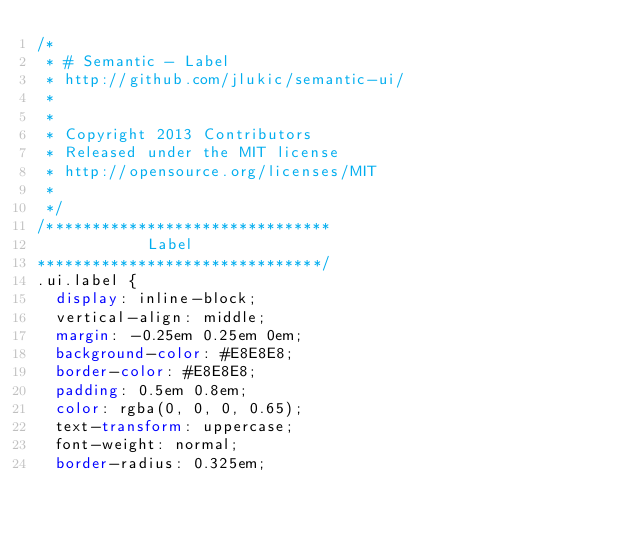Convert code to text. <code><loc_0><loc_0><loc_500><loc_500><_CSS_>/*
 * # Semantic - Label
 * http://github.com/jlukic/semantic-ui/
 *
 *
 * Copyright 2013 Contributors
 * Released under the MIT license
 * http://opensource.org/licenses/MIT
 *
 */
/*******************************
            Label
*******************************/
.ui.label {
  display: inline-block;
  vertical-align: middle;
  margin: -0.25em 0.25em 0em;
  background-color: #E8E8E8;
  border-color: #E8E8E8;
  padding: 0.5em 0.8em;
  color: rgba(0, 0, 0, 0.65);
  text-transform: uppercase;
  font-weight: normal;
  border-radius: 0.325em;</code> 